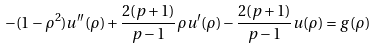Convert formula to latex. <formula><loc_0><loc_0><loc_500><loc_500>- ( 1 - \rho ^ { 2 } ) u ^ { \prime \prime } ( \rho ) + \frac { 2 ( p + 1 ) } { p - 1 } \rho u ^ { \prime } ( \rho ) - \frac { 2 ( p + 1 ) } { p - 1 } u ( \rho ) = g ( \rho )</formula> 